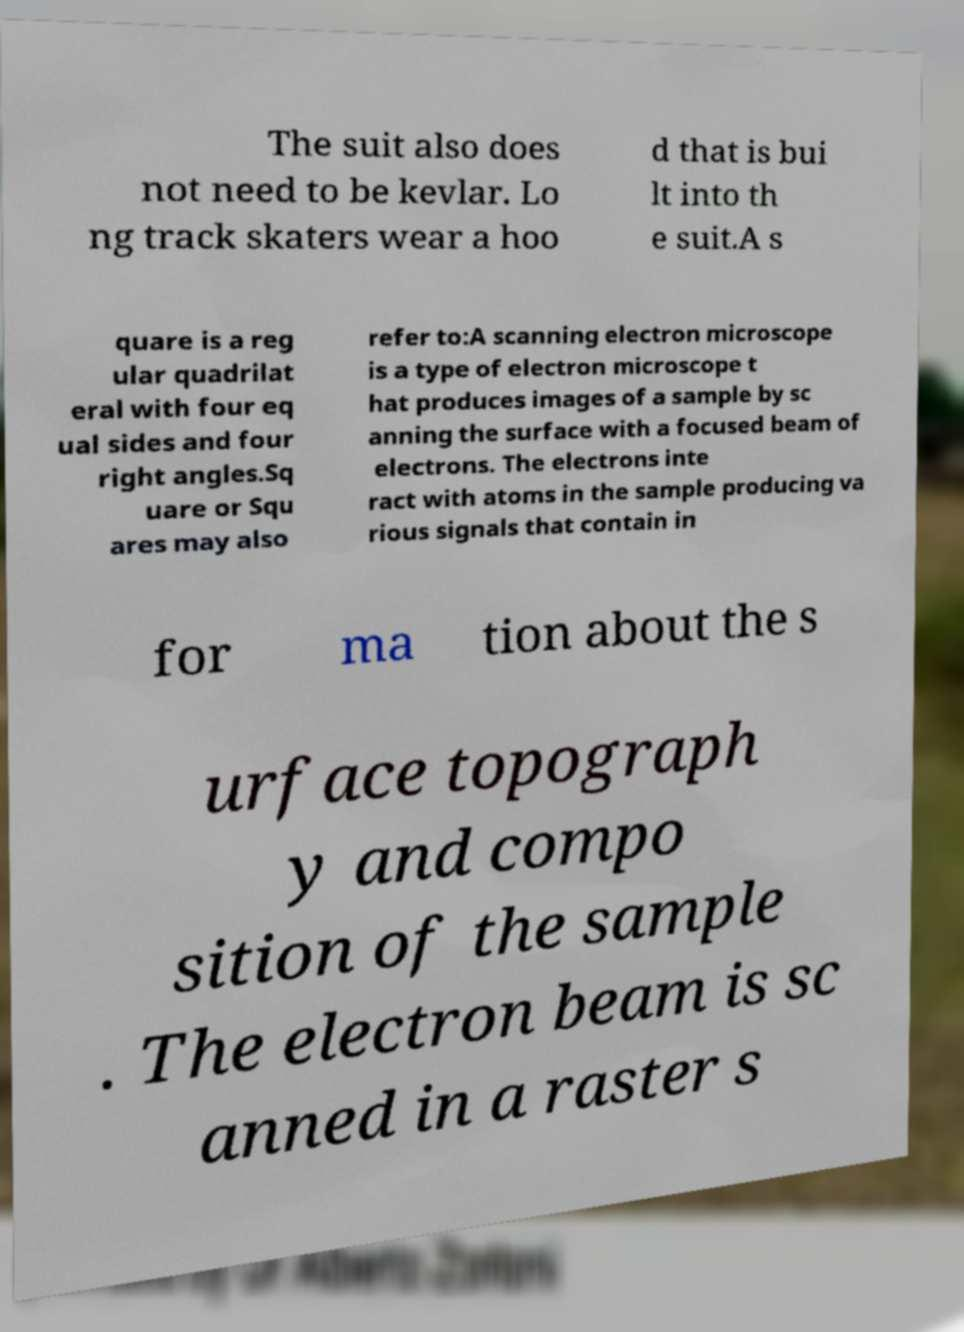For documentation purposes, I need the text within this image transcribed. Could you provide that? The suit also does not need to be kevlar. Lo ng track skaters wear a hoo d that is bui lt into th e suit.A s quare is a reg ular quadrilat eral with four eq ual sides and four right angles.Sq uare or Squ ares may also refer to:A scanning electron microscope is a type of electron microscope t hat produces images of a sample by sc anning the surface with a focused beam of electrons. The electrons inte ract with atoms in the sample producing va rious signals that contain in for ma tion about the s urface topograph y and compo sition of the sample . The electron beam is sc anned in a raster s 